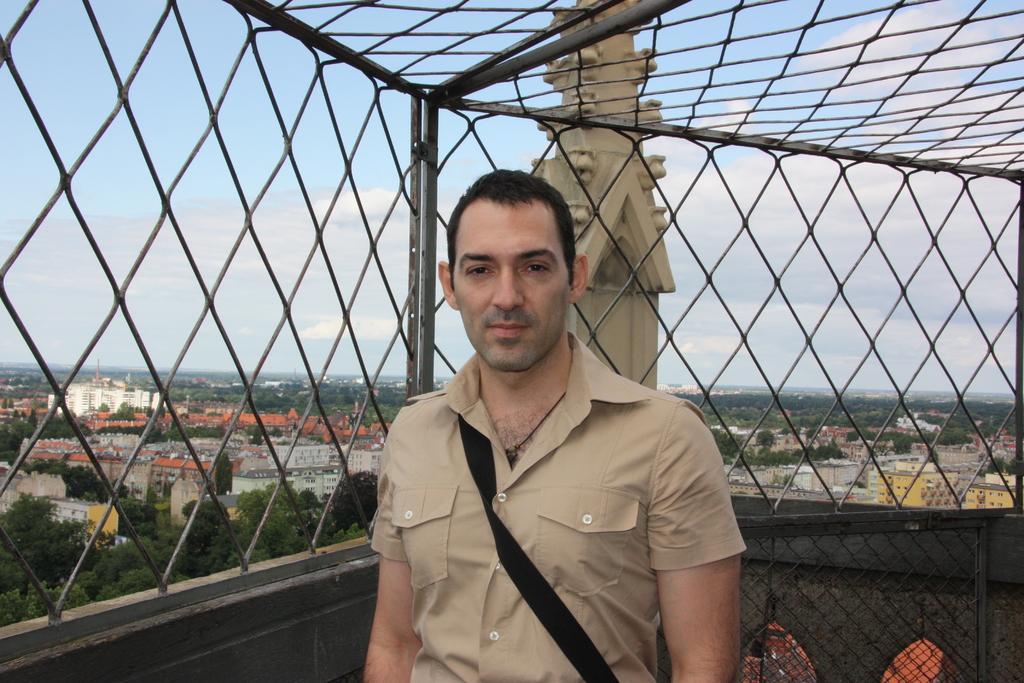Could you give a brief overview of what you see in this image? in this picture there is a person standing and there is a fence behind and above him and there are trees and buildings in the background. 